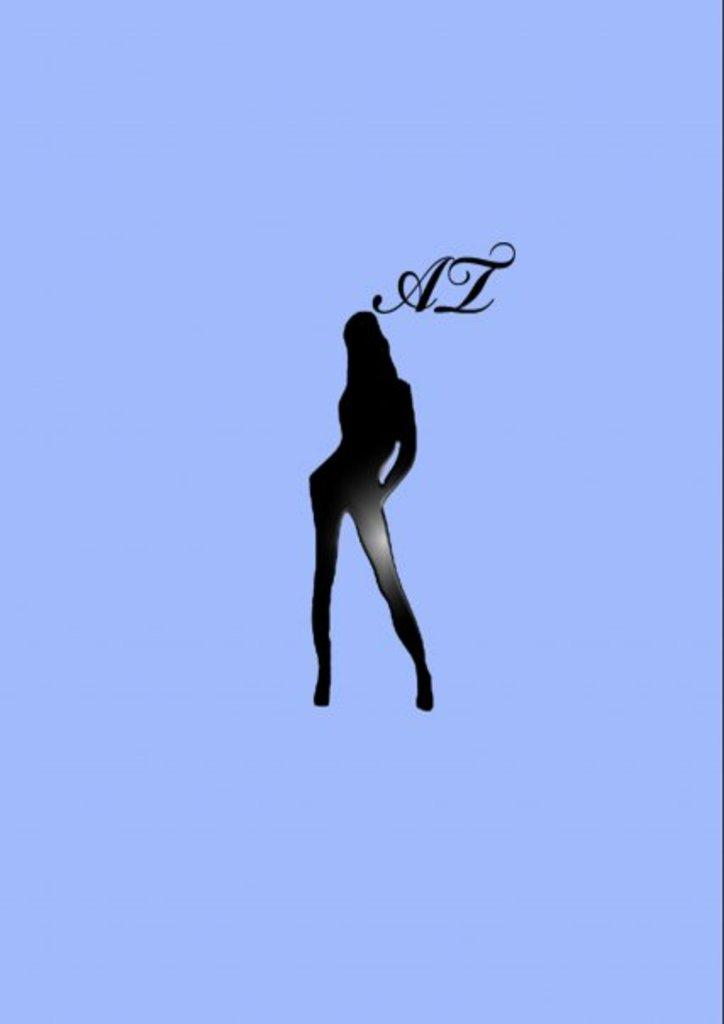What is depicted in the logo in the image? There is a logo of a person in the image. What color is the background of the image? The background of the image is blue. What type of plastic material is used to create the person's hat in the image? There is no hat visible on the person in the logo, and no mention of plastic material in the image. 